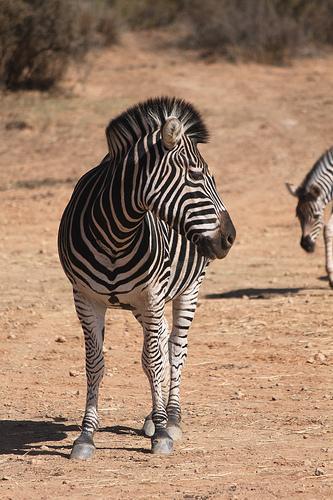How many zebras are there?
Give a very brief answer. 2. 